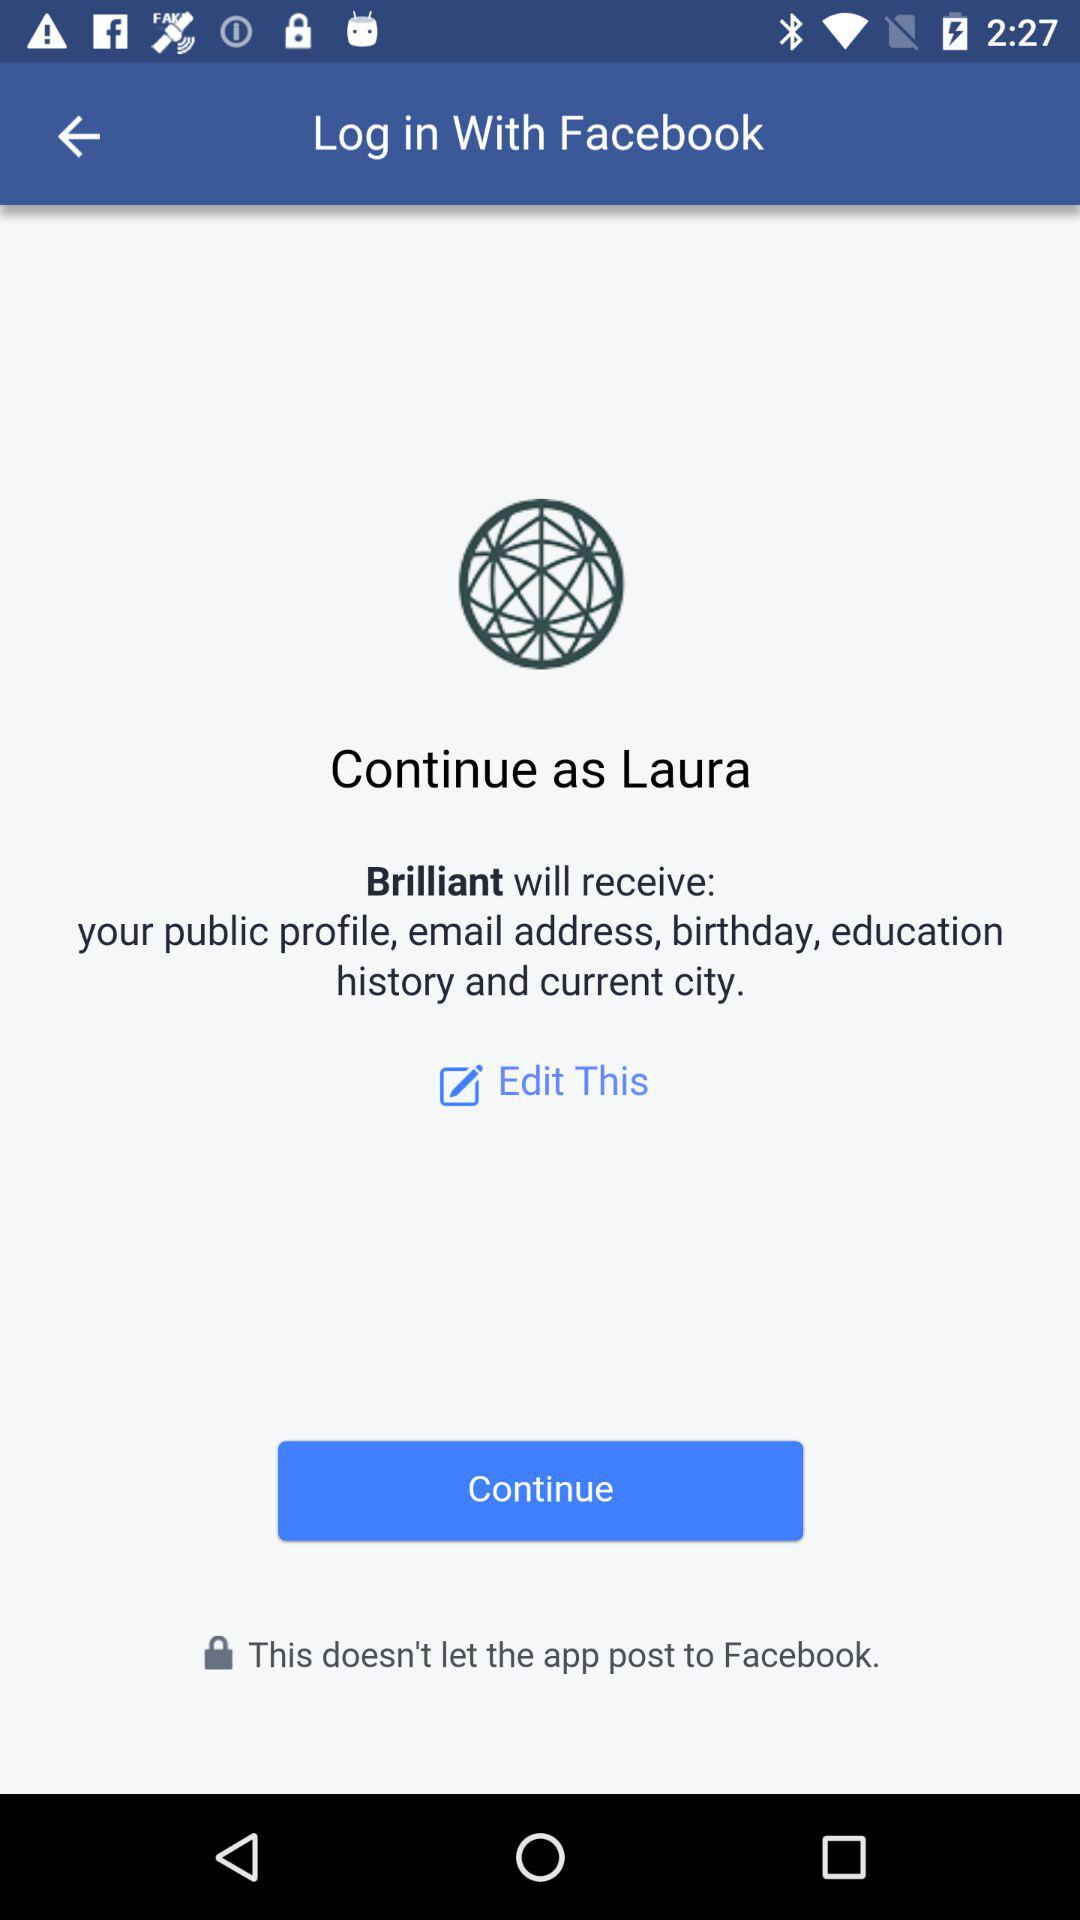What application is asking for permission? The application is "Brilliant". 